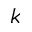<formula> <loc_0><loc_0><loc_500><loc_500>k</formula> 